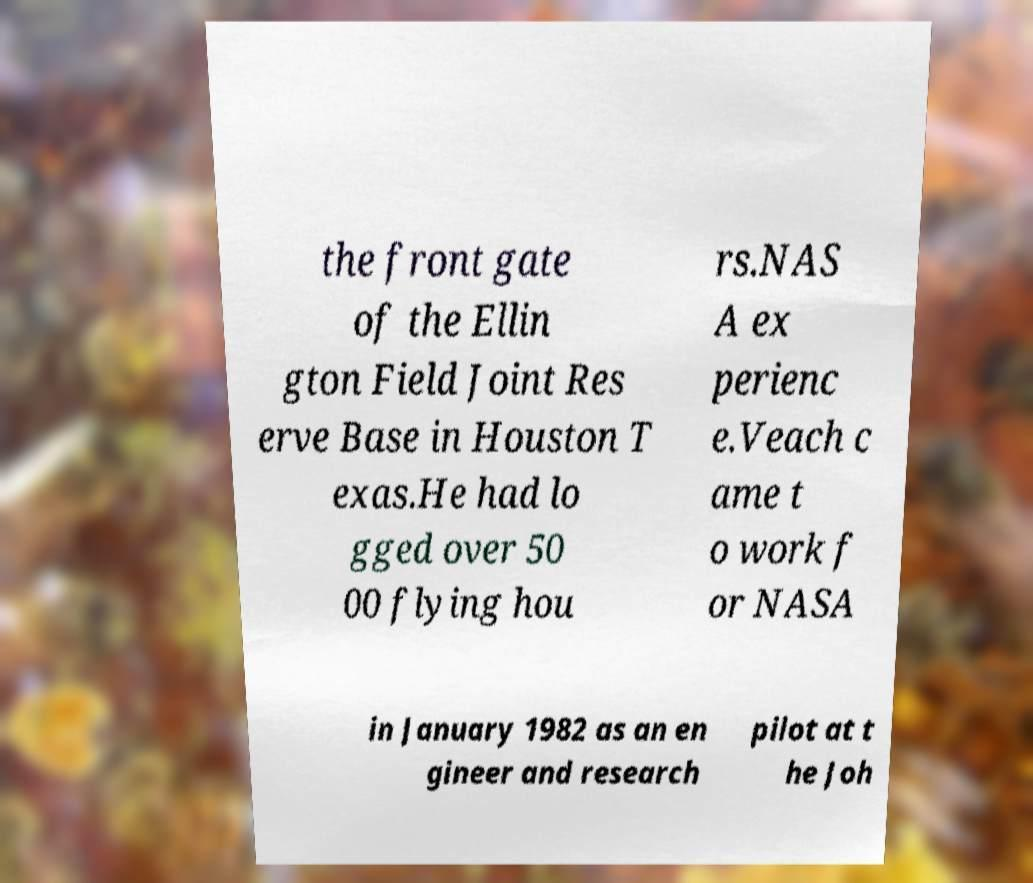For documentation purposes, I need the text within this image transcribed. Could you provide that? the front gate of the Ellin gton Field Joint Res erve Base in Houston T exas.He had lo gged over 50 00 flying hou rs.NAS A ex perienc e.Veach c ame t o work f or NASA in January 1982 as an en gineer and research pilot at t he Joh 